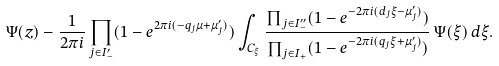Convert formula to latex. <formula><loc_0><loc_0><loc_500><loc_500>\Psi ( z ) - \frac { 1 } { 2 \pi i } \prod _ { j \in I _ { - } ^ { \prime } } ( 1 - e ^ { 2 \pi i ( - q _ { j } \mu + \mu _ { j } ^ { \prime } ) } ) \int _ { C _ { \xi } } \frac { \prod _ { j \in I _ { - } ^ { \prime \prime } } ( 1 - e ^ { - 2 \pi i ( d _ { j } \xi - \mu _ { j } ^ { \prime } ) } ) } { \prod _ { j \in I _ { + } } ( 1 - e ^ { - 2 \pi i ( q _ { j } \xi + \mu _ { j } ^ { \prime } ) } ) } \, \Psi ( \xi ) \, d \xi .</formula> 